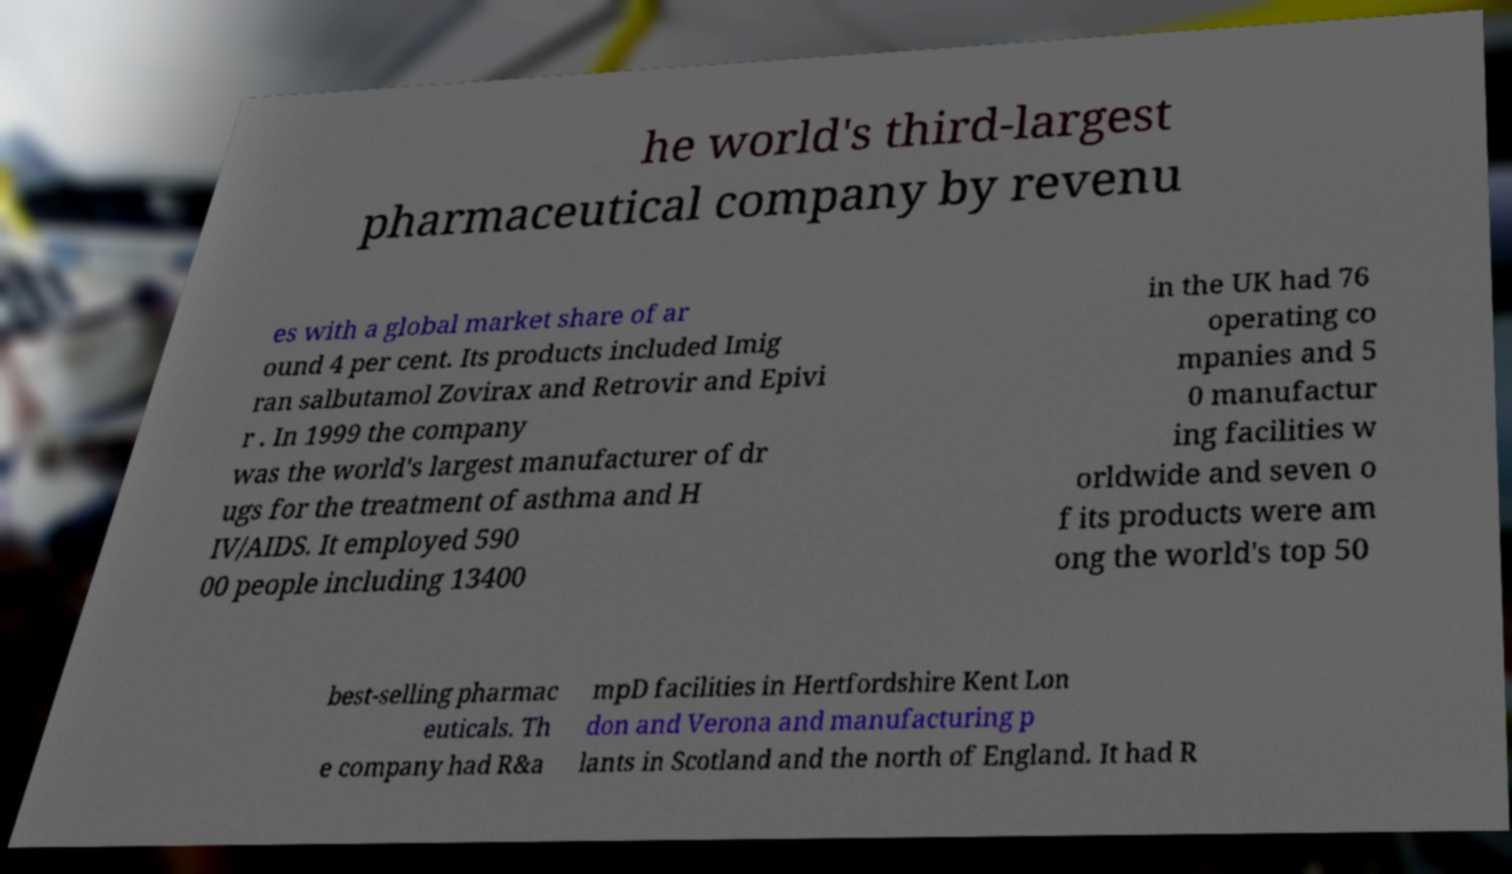I need the written content from this picture converted into text. Can you do that? he world's third-largest pharmaceutical company by revenu es with a global market share of ar ound 4 per cent. Its products included Imig ran salbutamol Zovirax and Retrovir and Epivi r . In 1999 the company was the world's largest manufacturer of dr ugs for the treatment of asthma and H IV/AIDS. It employed 590 00 people including 13400 in the UK had 76 operating co mpanies and 5 0 manufactur ing facilities w orldwide and seven o f its products were am ong the world's top 50 best-selling pharmac euticals. Th e company had R&a mpD facilities in Hertfordshire Kent Lon don and Verona and manufacturing p lants in Scotland and the north of England. It had R 